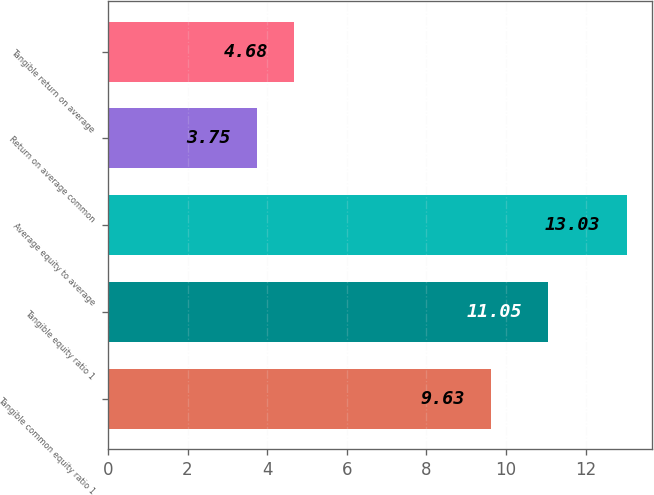Convert chart to OTSL. <chart><loc_0><loc_0><loc_500><loc_500><bar_chart><fcel>Tangible common equity ratio 1<fcel>Tangible equity ratio 1<fcel>Average equity to average<fcel>Return on average common<fcel>Tangible return on average<nl><fcel>9.63<fcel>11.05<fcel>13.03<fcel>3.75<fcel>4.68<nl></chart> 